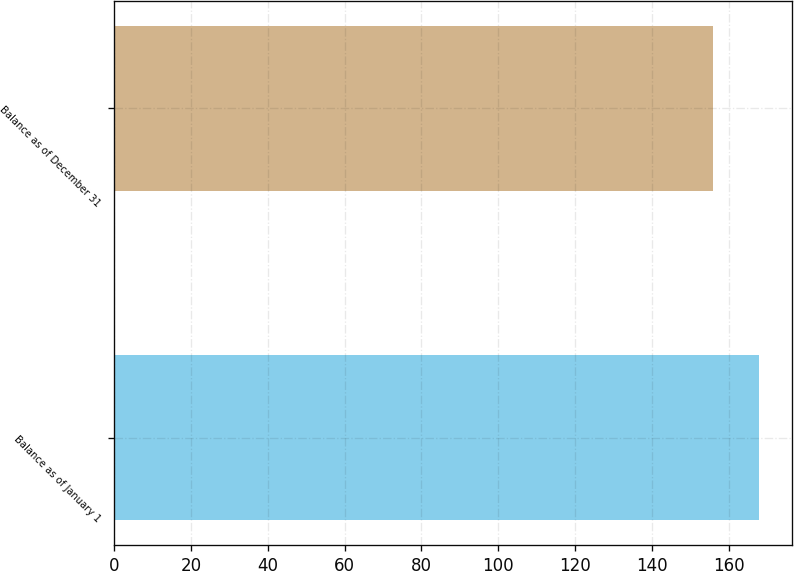Convert chart. <chart><loc_0><loc_0><loc_500><loc_500><bar_chart><fcel>Balance as of January 1<fcel>Balance as of December 31<nl><fcel>168<fcel>156<nl></chart> 